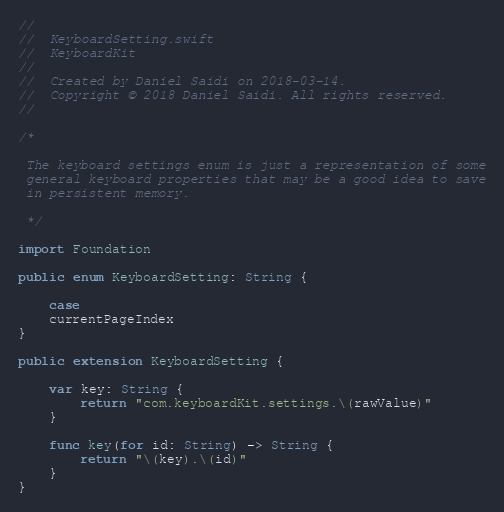Convert code to text. <code><loc_0><loc_0><loc_500><loc_500><_Swift_>//
//  KeyboardSetting.swift
//  KeyboardKit
//
//  Created by Daniel Saidi on 2018-03-14.
//  Copyright © 2018 Daniel Saidi. All rights reserved.
//

/*
 
 The keyboard settings enum is just a representation of some
 general keyboard properties that may be a good idea to save
 in persistent memory.
 
 */

import Foundation

public enum KeyboardSetting: String {
    
    case
    currentPageIndex
}

public extension KeyboardSetting {
    
    var key: String {
        return "com.keyboardKit.settings.\(rawValue)"
    }
    
    func key(for id: String) -> String {
        return "\(key).\(id)"
    }
}
</code> 